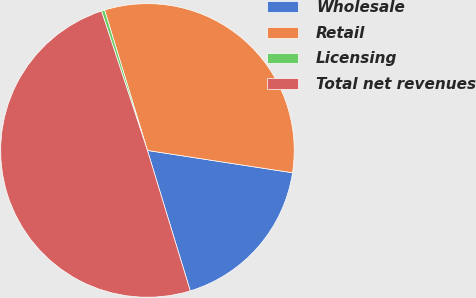<chart> <loc_0><loc_0><loc_500><loc_500><pie_chart><fcel>Wholesale<fcel>Retail<fcel>Licensing<fcel>Total net revenues<nl><fcel>17.86%<fcel>32.14%<fcel>0.36%<fcel>49.64%<nl></chart> 